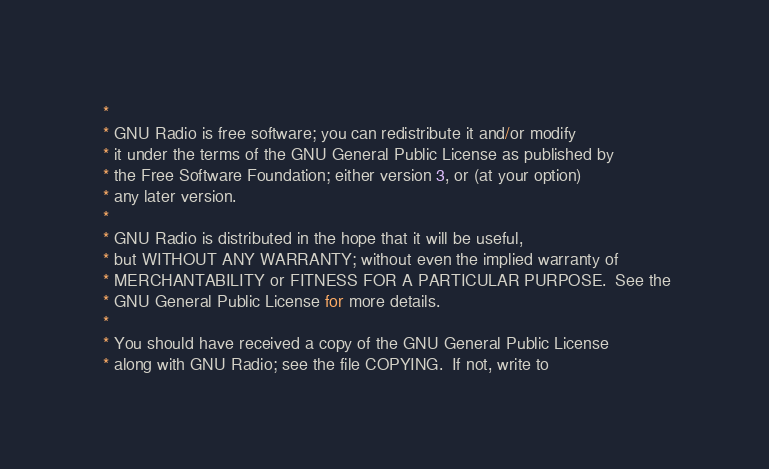Convert code to text. <code><loc_0><loc_0><loc_500><loc_500><_C_> *
 * GNU Radio is free software; you can redistribute it and/or modify
 * it under the terms of the GNU General Public License as published by
 * the Free Software Foundation; either version 3, or (at your option)
 * any later version.
 *
 * GNU Radio is distributed in the hope that it will be useful,
 * but WITHOUT ANY WARRANTY; without even the implied warranty of
 * MERCHANTABILITY or FITNESS FOR A PARTICULAR PURPOSE.  See the
 * GNU General Public License for more details.
 *
 * You should have received a copy of the GNU General Public License
 * along with GNU Radio; see the file COPYING.  If not, write to</code> 